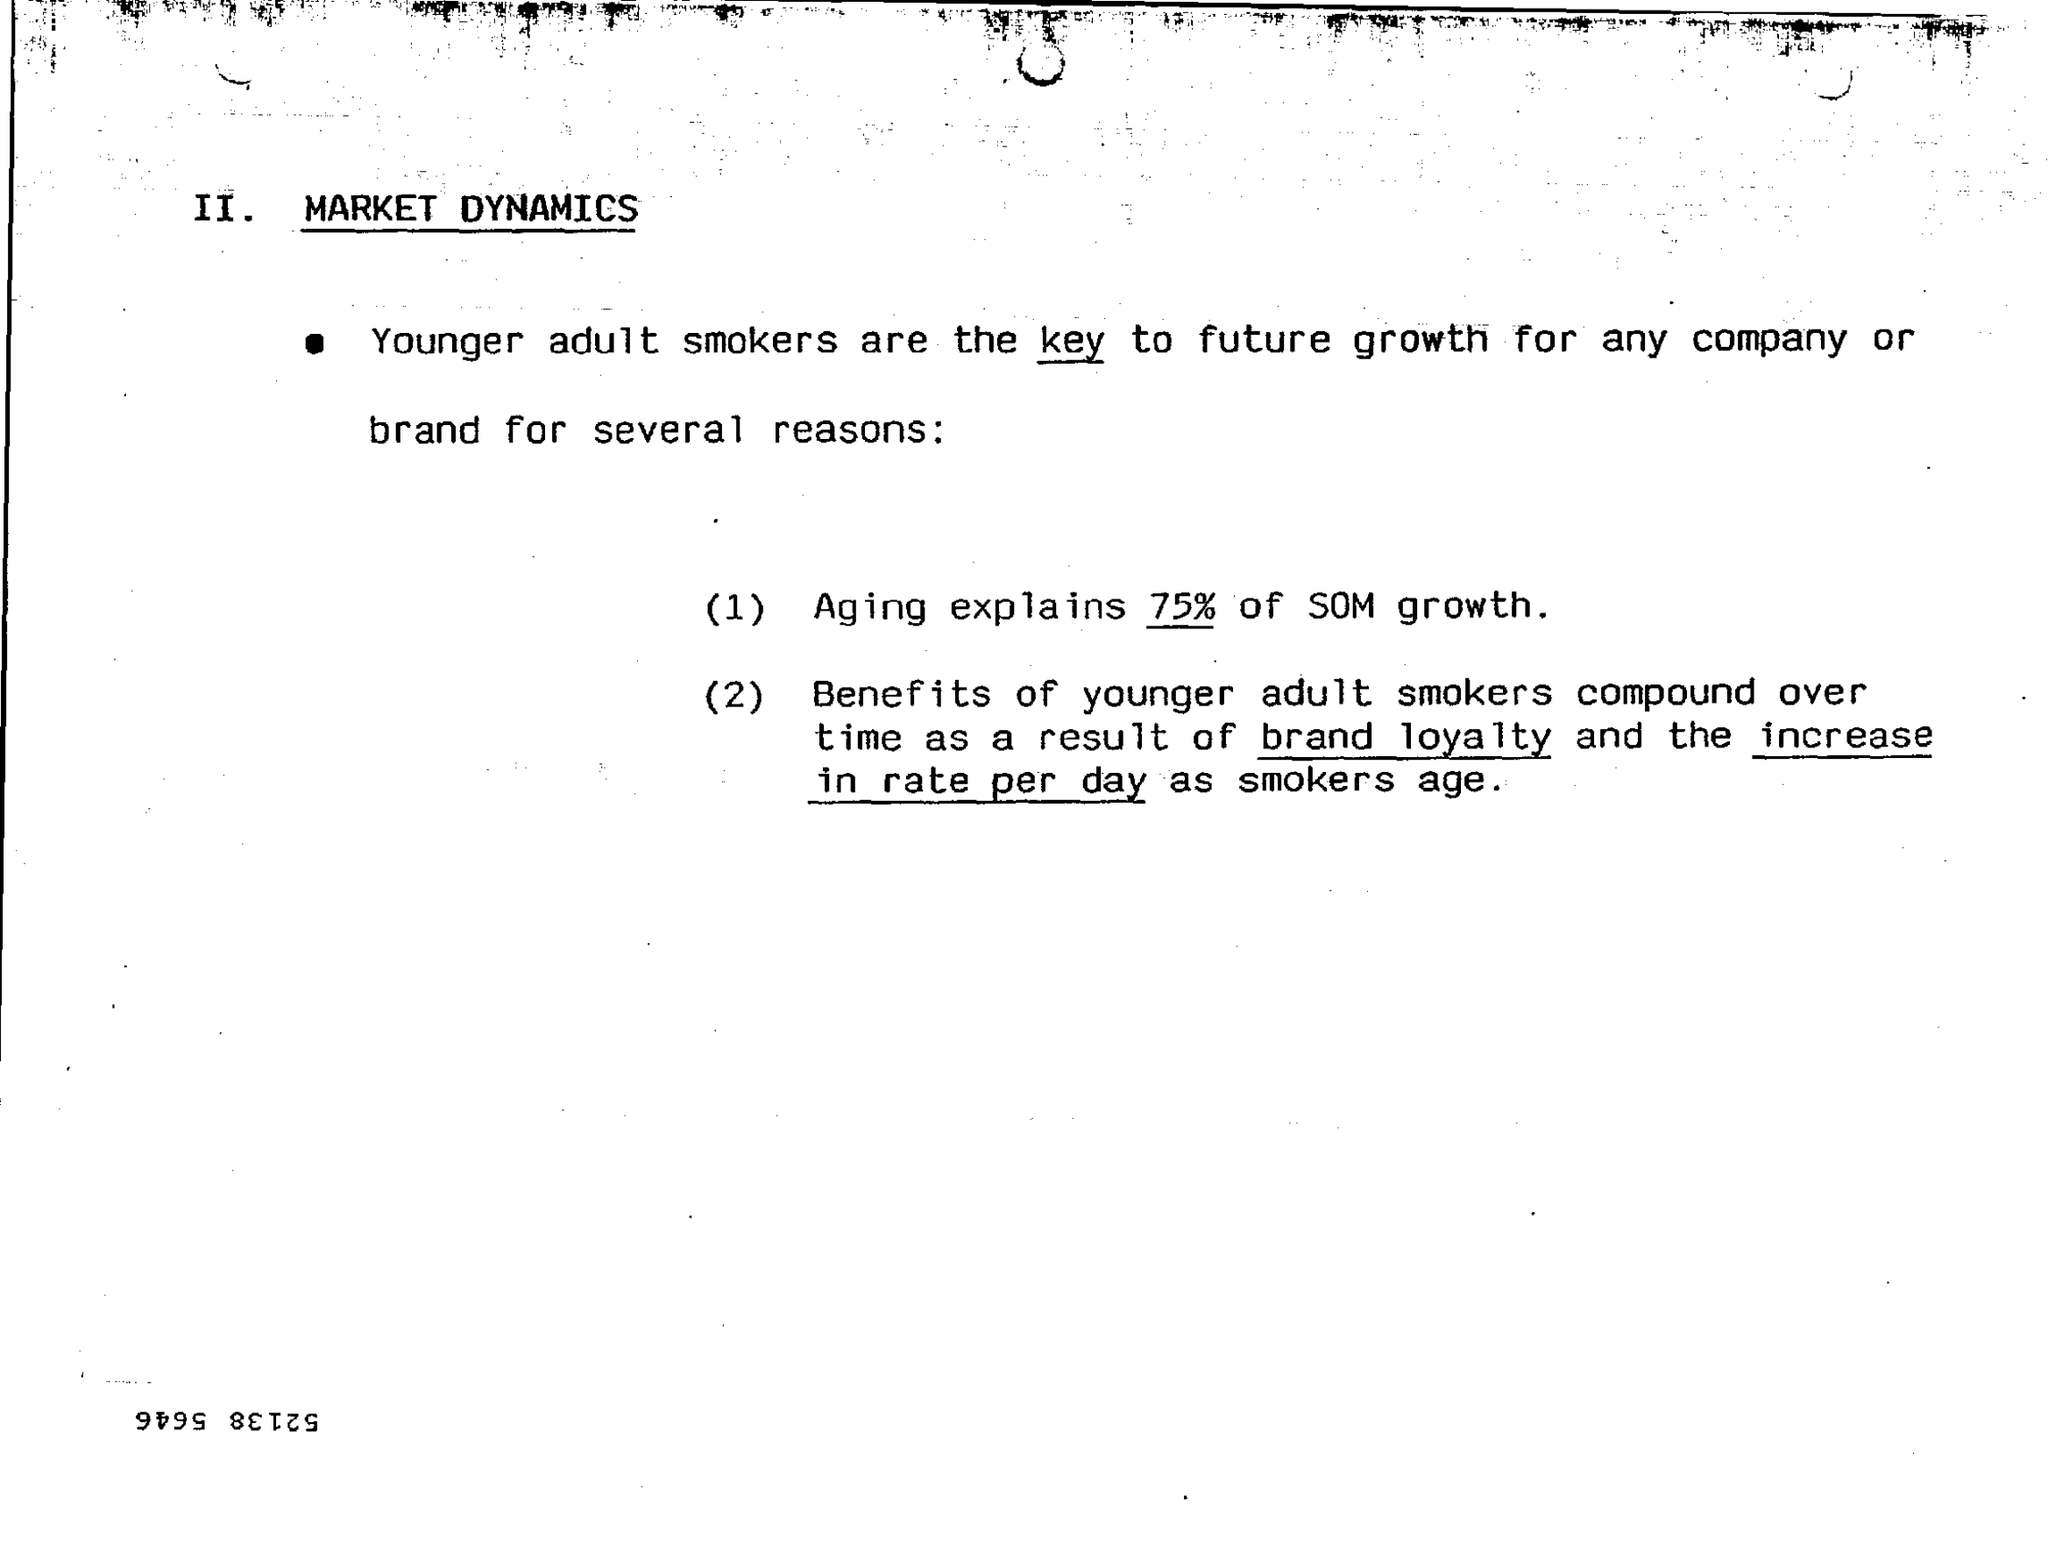Indicate a few pertinent items in this graphic. Younger adult smokers are the key to future growth for any company or brand, as they possess various qualities and characteristics that make them valuable assets. Aging is responsible for approximately 75% of the growth of the soma in Drosophila. 